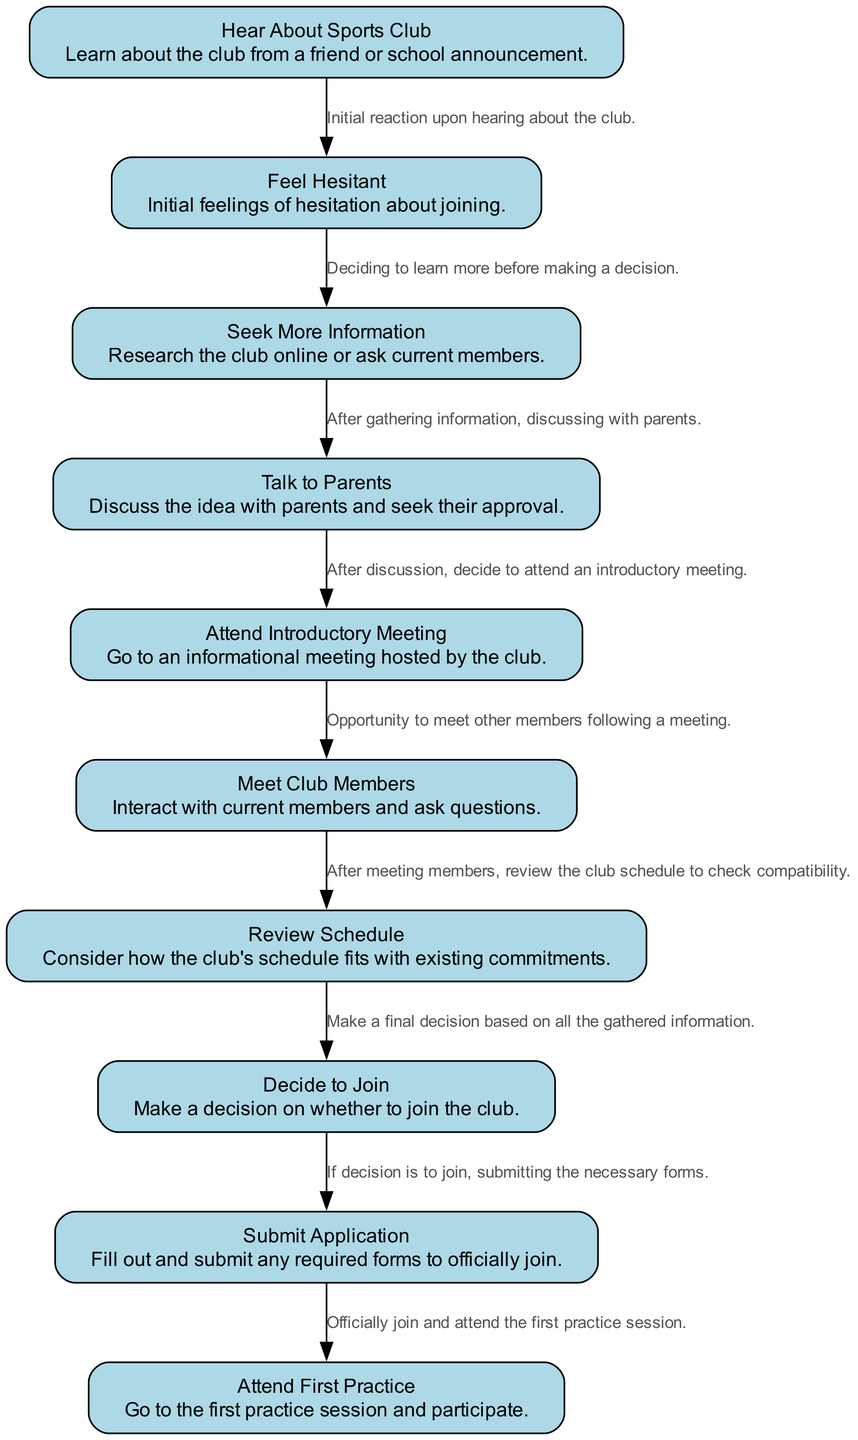What is the first activity in the diagram? The first activity listed in the diagram is "Hear About Sports Club," as it is the starting point from where the process begins.
Answer: Hear About Sports Club How many nodes are there in total? The diagram lists a total of 10 distinct activities as nodes, which corresponds to the various steps in the process of joining a sports club.
Answer: 10 What activity comes after "Feel Hesitant"? Following the activity "Feel Hesitant," the next step in the diagram is "Seek More Information," where the individual gathers further details before deciding.
Answer: Seek More Information Which activity leads to "Attend First Practice"? The activity that leads to "Attend First Practice" is "Submit Application," as this step is necessary for officially joining the club and participating in practices.
Answer: Submit Application What are the last two activities in the diagram? The last two activities listed in the process are "Submit Application" and "Attend First Practice," indicating the final steps one takes once the decision to join has been made.
Answer: Submit Application, Attend First Practice Which activity requires talking to parents? The activity that specifically involves talking to parents is "Talk to Parents," which follows the information-seeking phase and is crucial for obtaining parental approval.
Answer: Talk to Parents What transition occurs after "Meet Club Members"? The transition following "Meet Club Members" is "Review Schedule," where the individual evaluates the compatibility of their schedule with the club activities.
Answer: Review Schedule What is the main purpose of the "Attend Introductory Meeting"? The main purpose of the "Attend Introductory Meeting" is to provide an opportunity for potential members to gather information about the club and engage with current members.
Answer: Gather information How does someone decide whether to join the sports club? The decision to join is reached during the "Decide to Join" activity, which is based on the information and experiences gathered throughout the earlier activities in the diagram.
Answer: Evaluate gathered information What is the main action taken after "Decide to Join"? After deciding to join the club, the main action taken is "Submit Application," which involves filling out and submitting any necessary forms to formalize the membership.
Answer: Submit Application 